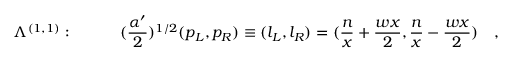Convert formula to latex. <formula><loc_0><loc_0><loc_500><loc_500>\Lambda ^ { ( 1 , 1 ) } \colon \quad ( { \frac { \alpha ^ { \prime } } { 2 } } ) ^ { 1 / 2 } ( p _ { L } , p _ { R } ) \equiv ( l _ { L } , l _ { R } ) = ( { \frac { n } { x } } + { \frac { w x } { 2 } } , { \frac { n } { x } } - { \frac { w x } { 2 } } ) \quad ,</formula> 